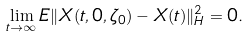<formula> <loc_0><loc_0><loc_500><loc_500>\lim _ { t \rightarrow \infty } E \| X ( t , 0 , \zeta _ { 0 } ) - X ( t ) \| _ { H } ^ { 2 } = 0 .</formula> 